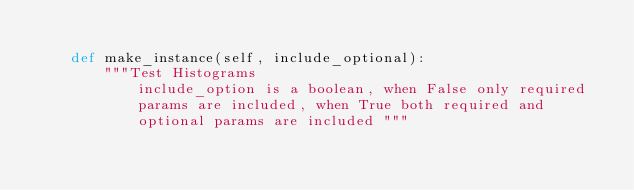<code> <loc_0><loc_0><loc_500><loc_500><_Python_>
    def make_instance(self, include_optional):
        """Test Histograms
            include_option is a boolean, when False only required
            params are included, when True both required and
            optional params are included """</code> 